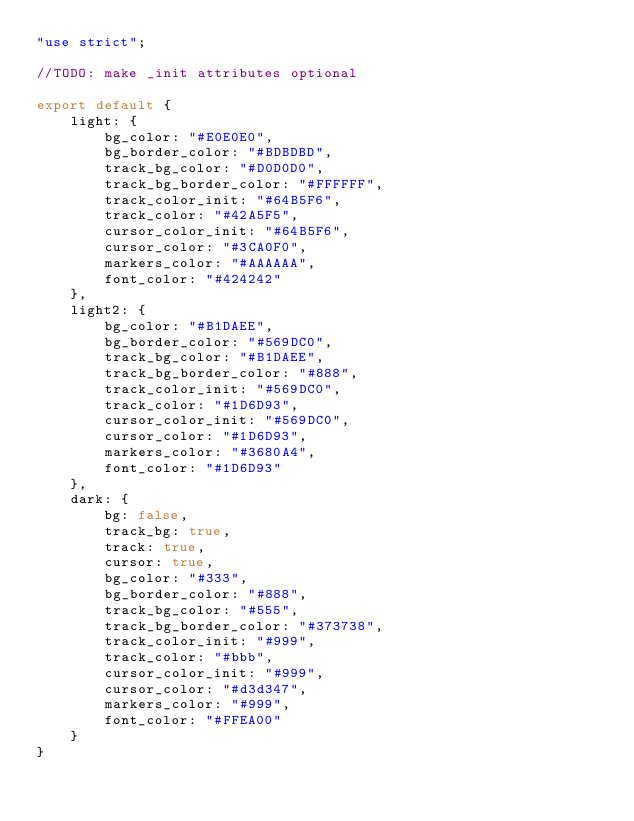<code> <loc_0><loc_0><loc_500><loc_500><_JavaScript_>"use strict";

//TODO: make _init attributes optional

export default {
    light: {
        bg_color: "#E0E0E0",
        bg_border_color: "#BDBDBD",
        track_bg_color: "#D0D0D0",
        track_bg_border_color: "#FFFFFF",
        track_color_init: "#64B5F6",
        track_color: "#42A5F5",
        cursor_color_init: "#64B5F6",
        cursor_color: "#3CA0F0",
        markers_color: "#AAAAAA",
        font_color: "#424242"
    },
    light2: {
        bg_color: "#B1DAEE",
        bg_border_color: "#569DC0",
        track_bg_color: "#B1DAEE",
        track_bg_border_color: "#888",
        track_color_init: "#569DC0",
        track_color: "#1D6D93",
        cursor_color_init: "#569DC0",
        cursor_color: "#1D6D93",
        markers_color: "#3680A4",
        font_color: "#1D6D93"
    },
    dark: {
        bg: false,
        track_bg: true,
        track: true,
        cursor: true,
        bg_color: "#333",
        bg_border_color: "#888",
        track_bg_color: "#555",
        track_bg_border_color: "#373738",
        track_color_init: "#999",
        track_color: "#bbb",
        cursor_color_init: "#999",
        cursor_color: "#d3d347",
        markers_color: "#999",
        font_color: "#FFEA00"
    }
}
</code> 